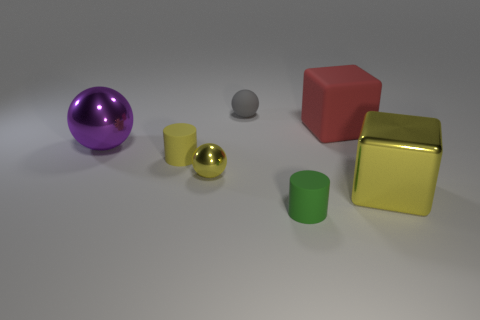If I were to arrange these objects from left to right by size, starting with the smallest, what would that order be? Arranging the objects from the smallest to largest, starting with the smallest, would be the small grey cylinder, the small yellow reflective sphere, the small green cylinder, the large purple sphere, the red cube, and ending with the large yellow metallic cube. 